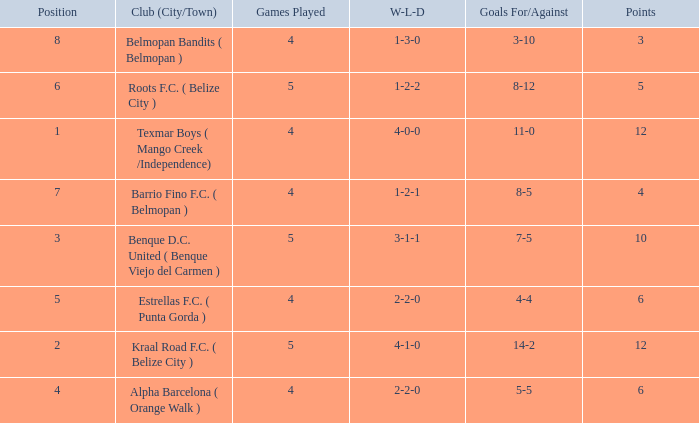What's the w-l-d with position being 1 4-0-0. 